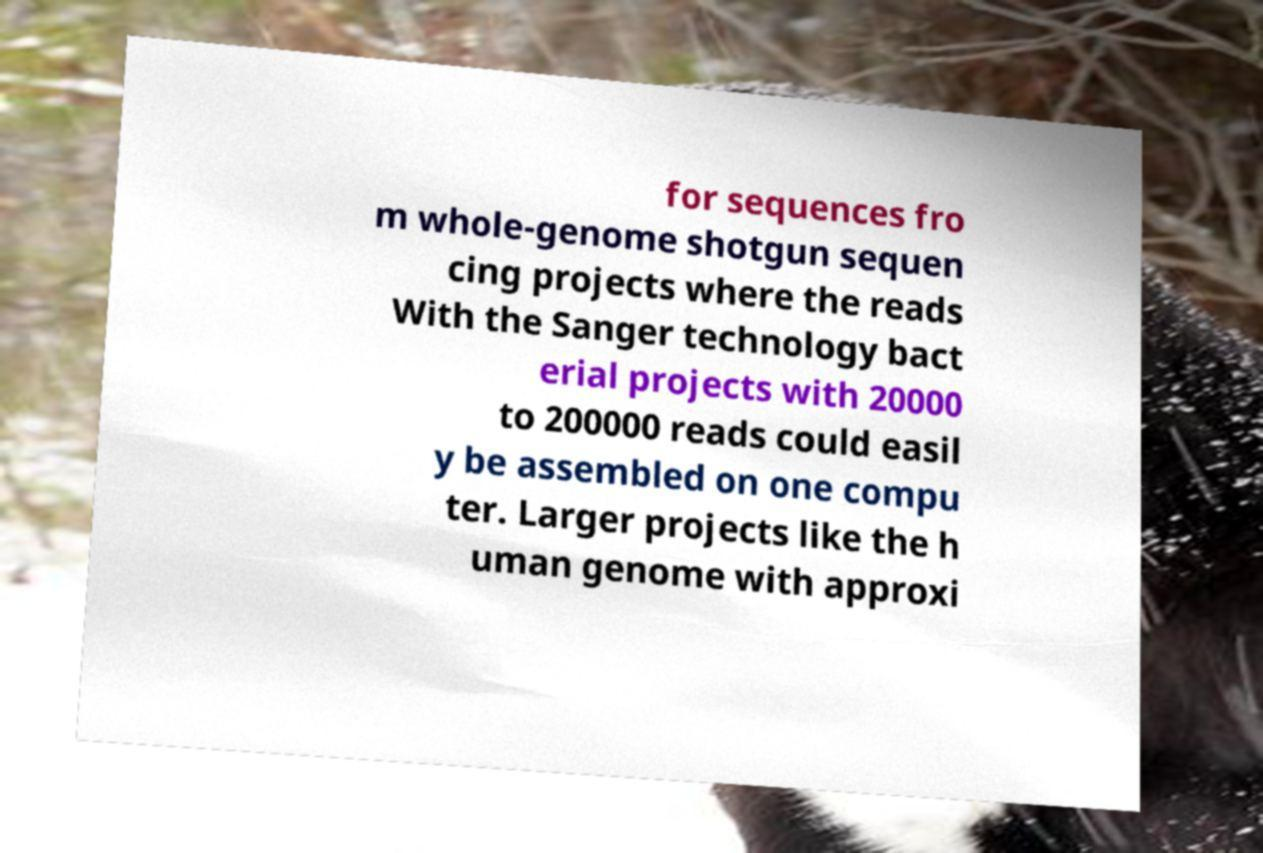Could you extract and type out the text from this image? for sequences fro m whole-genome shotgun sequen cing projects where the reads With the Sanger technology bact erial projects with 20000 to 200000 reads could easil y be assembled on one compu ter. Larger projects like the h uman genome with approxi 